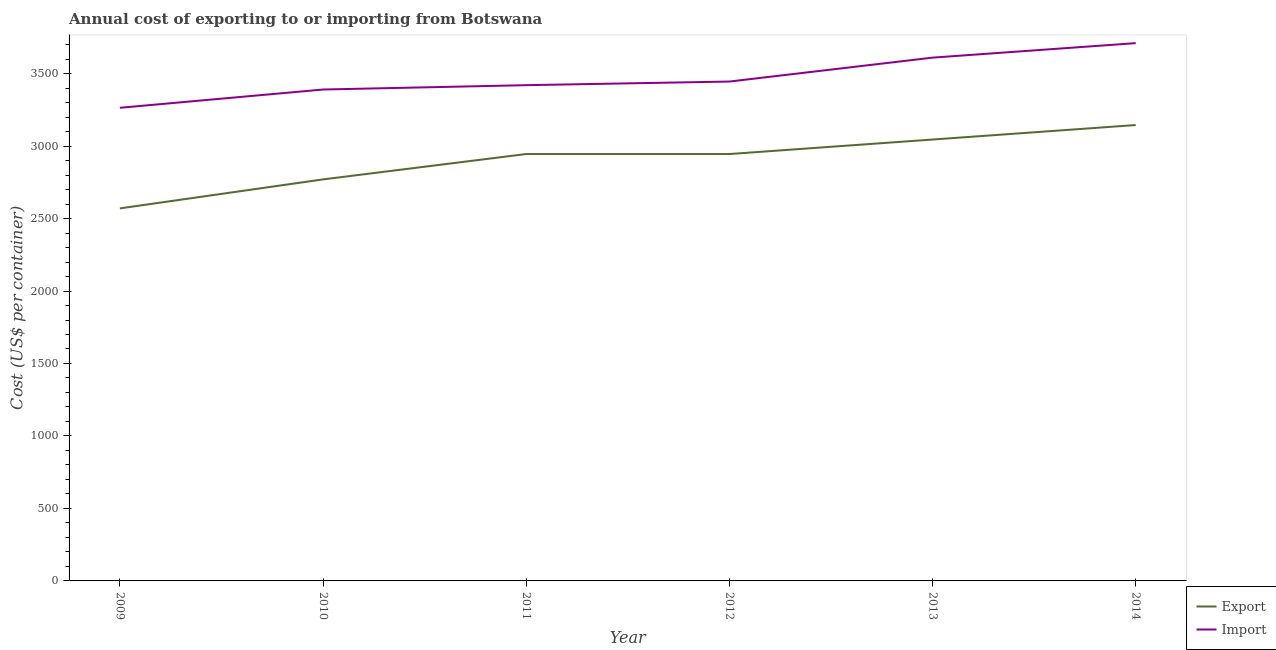What is the export cost in 2010?
Provide a short and direct response. 2770. Across all years, what is the maximum import cost?
Offer a terse response. 3710. Across all years, what is the minimum export cost?
Keep it short and to the point. 2570. In which year was the export cost minimum?
Provide a succinct answer. 2009. What is the total export cost in the graph?
Offer a very short reply. 1.74e+04. What is the difference between the export cost in 2010 and that in 2013?
Your response must be concise. -275. What is the difference between the import cost in 2013 and the export cost in 2012?
Provide a short and direct response. 665. What is the average export cost per year?
Give a very brief answer. 2903.33. In the year 2011, what is the difference between the import cost and export cost?
Offer a very short reply. 475. In how many years, is the import cost greater than 1700 US$?
Provide a short and direct response. 6. What is the ratio of the import cost in 2013 to that in 2014?
Your answer should be compact. 0.97. Is the import cost in 2010 less than that in 2012?
Your answer should be very brief. Yes. Is the difference between the import cost in 2009 and 2014 greater than the difference between the export cost in 2009 and 2014?
Provide a succinct answer. Yes. What is the difference between the highest and the second highest export cost?
Your answer should be compact. 100. What is the difference between the highest and the lowest export cost?
Provide a short and direct response. 575. In how many years, is the export cost greater than the average export cost taken over all years?
Your answer should be very brief. 4. Is the sum of the export cost in 2009 and 2012 greater than the maximum import cost across all years?
Your answer should be compact. Yes. Is the export cost strictly less than the import cost over the years?
Your answer should be compact. Yes. Does the graph contain grids?
Your response must be concise. No. How many legend labels are there?
Provide a short and direct response. 2. How are the legend labels stacked?
Make the answer very short. Vertical. What is the title of the graph?
Give a very brief answer. Annual cost of exporting to or importing from Botswana. What is the label or title of the Y-axis?
Your answer should be very brief. Cost (US$ per container). What is the Cost (US$ per container) of Export in 2009?
Provide a succinct answer. 2570. What is the Cost (US$ per container) of Import in 2009?
Your response must be concise. 3264. What is the Cost (US$ per container) in Export in 2010?
Offer a terse response. 2770. What is the Cost (US$ per container) in Import in 2010?
Offer a terse response. 3390. What is the Cost (US$ per container) in Export in 2011?
Make the answer very short. 2945. What is the Cost (US$ per container) in Import in 2011?
Make the answer very short. 3420. What is the Cost (US$ per container) in Export in 2012?
Offer a very short reply. 2945. What is the Cost (US$ per container) in Import in 2012?
Keep it short and to the point. 3445. What is the Cost (US$ per container) in Export in 2013?
Your answer should be compact. 3045. What is the Cost (US$ per container) in Import in 2013?
Give a very brief answer. 3610. What is the Cost (US$ per container) of Export in 2014?
Keep it short and to the point. 3145. What is the Cost (US$ per container) in Import in 2014?
Offer a very short reply. 3710. Across all years, what is the maximum Cost (US$ per container) of Export?
Make the answer very short. 3145. Across all years, what is the maximum Cost (US$ per container) in Import?
Provide a short and direct response. 3710. Across all years, what is the minimum Cost (US$ per container) of Export?
Provide a short and direct response. 2570. Across all years, what is the minimum Cost (US$ per container) of Import?
Your answer should be compact. 3264. What is the total Cost (US$ per container) of Export in the graph?
Give a very brief answer. 1.74e+04. What is the total Cost (US$ per container) in Import in the graph?
Your answer should be very brief. 2.08e+04. What is the difference between the Cost (US$ per container) of Export in 2009 and that in 2010?
Provide a short and direct response. -200. What is the difference between the Cost (US$ per container) of Import in 2009 and that in 2010?
Provide a succinct answer. -126. What is the difference between the Cost (US$ per container) of Export in 2009 and that in 2011?
Make the answer very short. -375. What is the difference between the Cost (US$ per container) of Import in 2009 and that in 2011?
Ensure brevity in your answer.  -156. What is the difference between the Cost (US$ per container) of Export in 2009 and that in 2012?
Make the answer very short. -375. What is the difference between the Cost (US$ per container) in Import in 2009 and that in 2012?
Keep it short and to the point. -181. What is the difference between the Cost (US$ per container) of Export in 2009 and that in 2013?
Ensure brevity in your answer.  -475. What is the difference between the Cost (US$ per container) of Import in 2009 and that in 2013?
Offer a very short reply. -346. What is the difference between the Cost (US$ per container) of Export in 2009 and that in 2014?
Your answer should be very brief. -575. What is the difference between the Cost (US$ per container) in Import in 2009 and that in 2014?
Offer a terse response. -446. What is the difference between the Cost (US$ per container) of Export in 2010 and that in 2011?
Your answer should be very brief. -175. What is the difference between the Cost (US$ per container) of Export in 2010 and that in 2012?
Your response must be concise. -175. What is the difference between the Cost (US$ per container) of Import in 2010 and that in 2012?
Offer a terse response. -55. What is the difference between the Cost (US$ per container) in Export in 2010 and that in 2013?
Keep it short and to the point. -275. What is the difference between the Cost (US$ per container) of Import in 2010 and that in 2013?
Provide a short and direct response. -220. What is the difference between the Cost (US$ per container) of Export in 2010 and that in 2014?
Give a very brief answer. -375. What is the difference between the Cost (US$ per container) of Import in 2010 and that in 2014?
Provide a short and direct response. -320. What is the difference between the Cost (US$ per container) of Export in 2011 and that in 2012?
Provide a short and direct response. 0. What is the difference between the Cost (US$ per container) in Import in 2011 and that in 2012?
Offer a very short reply. -25. What is the difference between the Cost (US$ per container) of Export in 2011 and that in 2013?
Ensure brevity in your answer.  -100. What is the difference between the Cost (US$ per container) in Import in 2011 and that in 2013?
Your answer should be compact. -190. What is the difference between the Cost (US$ per container) in Export in 2011 and that in 2014?
Offer a very short reply. -200. What is the difference between the Cost (US$ per container) of Import in 2011 and that in 2014?
Your answer should be very brief. -290. What is the difference between the Cost (US$ per container) of Export in 2012 and that in 2013?
Ensure brevity in your answer.  -100. What is the difference between the Cost (US$ per container) of Import in 2012 and that in 2013?
Offer a terse response. -165. What is the difference between the Cost (US$ per container) in Export in 2012 and that in 2014?
Ensure brevity in your answer.  -200. What is the difference between the Cost (US$ per container) in Import in 2012 and that in 2014?
Offer a very short reply. -265. What is the difference between the Cost (US$ per container) in Export in 2013 and that in 2014?
Provide a short and direct response. -100. What is the difference between the Cost (US$ per container) in Import in 2013 and that in 2014?
Provide a short and direct response. -100. What is the difference between the Cost (US$ per container) in Export in 2009 and the Cost (US$ per container) in Import in 2010?
Offer a very short reply. -820. What is the difference between the Cost (US$ per container) in Export in 2009 and the Cost (US$ per container) in Import in 2011?
Offer a terse response. -850. What is the difference between the Cost (US$ per container) in Export in 2009 and the Cost (US$ per container) in Import in 2012?
Your answer should be compact. -875. What is the difference between the Cost (US$ per container) in Export in 2009 and the Cost (US$ per container) in Import in 2013?
Your response must be concise. -1040. What is the difference between the Cost (US$ per container) in Export in 2009 and the Cost (US$ per container) in Import in 2014?
Your answer should be compact. -1140. What is the difference between the Cost (US$ per container) of Export in 2010 and the Cost (US$ per container) of Import in 2011?
Ensure brevity in your answer.  -650. What is the difference between the Cost (US$ per container) in Export in 2010 and the Cost (US$ per container) in Import in 2012?
Offer a very short reply. -675. What is the difference between the Cost (US$ per container) in Export in 2010 and the Cost (US$ per container) in Import in 2013?
Ensure brevity in your answer.  -840. What is the difference between the Cost (US$ per container) of Export in 2010 and the Cost (US$ per container) of Import in 2014?
Offer a very short reply. -940. What is the difference between the Cost (US$ per container) of Export in 2011 and the Cost (US$ per container) of Import in 2012?
Offer a terse response. -500. What is the difference between the Cost (US$ per container) in Export in 2011 and the Cost (US$ per container) in Import in 2013?
Offer a very short reply. -665. What is the difference between the Cost (US$ per container) of Export in 2011 and the Cost (US$ per container) of Import in 2014?
Give a very brief answer. -765. What is the difference between the Cost (US$ per container) of Export in 2012 and the Cost (US$ per container) of Import in 2013?
Ensure brevity in your answer.  -665. What is the difference between the Cost (US$ per container) in Export in 2012 and the Cost (US$ per container) in Import in 2014?
Offer a very short reply. -765. What is the difference between the Cost (US$ per container) in Export in 2013 and the Cost (US$ per container) in Import in 2014?
Keep it short and to the point. -665. What is the average Cost (US$ per container) of Export per year?
Keep it short and to the point. 2903.33. What is the average Cost (US$ per container) of Import per year?
Your answer should be very brief. 3473.17. In the year 2009, what is the difference between the Cost (US$ per container) of Export and Cost (US$ per container) of Import?
Your answer should be compact. -694. In the year 2010, what is the difference between the Cost (US$ per container) in Export and Cost (US$ per container) in Import?
Make the answer very short. -620. In the year 2011, what is the difference between the Cost (US$ per container) in Export and Cost (US$ per container) in Import?
Keep it short and to the point. -475. In the year 2012, what is the difference between the Cost (US$ per container) of Export and Cost (US$ per container) of Import?
Your response must be concise. -500. In the year 2013, what is the difference between the Cost (US$ per container) in Export and Cost (US$ per container) in Import?
Make the answer very short. -565. In the year 2014, what is the difference between the Cost (US$ per container) of Export and Cost (US$ per container) of Import?
Keep it short and to the point. -565. What is the ratio of the Cost (US$ per container) of Export in 2009 to that in 2010?
Your answer should be very brief. 0.93. What is the ratio of the Cost (US$ per container) in Import in 2009 to that in 2010?
Provide a short and direct response. 0.96. What is the ratio of the Cost (US$ per container) of Export in 2009 to that in 2011?
Give a very brief answer. 0.87. What is the ratio of the Cost (US$ per container) in Import in 2009 to that in 2011?
Keep it short and to the point. 0.95. What is the ratio of the Cost (US$ per container) of Export in 2009 to that in 2012?
Offer a very short reply. 0.87. What is the ratio of the Cost (US$ per container) of Import in 2009 to that in 2012?
Ensure brevity in your answer.  0.95. What is the ratio of the Cost (US$ per container) of Export in 2009 to that in 2013?
Offer a very short reply. 0.84. What is the ratio of the Cost (US$ per container) in Import in 2009 to that in 2013?
Your answer should be very brief. 0.9. What is the ratio of the Cost (US$ per container) of Export in 2009 to that in 2014?
Offer a very short reply. 0.82. What is the ratio of the Cost (US$ per container) of Import in 2009 to that in 2014?
Offer a terse response. 0.88. What is the ratio of the Cost (US$ per container) of Export in 2010 to that in 2011?
Make the answer very short. 0.94. What is the ratio of the Cost (US$ per container) of Import in 2010 to that in 2011?
Provide a short and direct response. 0.99. What is the ratio of the Cost (US$ per container) in Export in 2010 to that in 2012?
Provide a short and direct response. 0.94. What is the ratio of the Cost (US$ per container) in Import in 2010 to that in 2012?
Ensure brevity in your answer.  0.98. What is the ratio of the Cost (US$ per container) in Export in 2010 to that in 2013?
Keep it short and to the point. 0.91. What is the ratio of the Cost (US$ per container) in Import in 2010 to that in 2013?
Keep it short and to the point. 0.94. What is the ratio of the Cost (US$ per container) of Export in 2010 to that in 2014?
Provide a short and direct response. 0.88. What is the ratio of the Cost (US$ per container) of Import in 2010 to that in 2014?
Your answer should be compact. 0.91. What is the ratio of the Cost (US$ per container) in Import in 2011 to that in 2012?
Keep it short and to the point. 0.99. What is the ratio of the Cost (US$ per container) of Export in 2011 to that in 2013?
Keep it short and to the point. 0.97. What is the ratio of the Cost (US$ per container) of Export in 2011 to that in 2014?
Offer a terse response. 0.94. What is the ratio of the Cost (US$ per container) of Import in 2011 to that in 2014?
Your answer should be very brief. 0.92. What is the ratio of the Cost (US$ per container) of Export in 2012 to that in 2013?
Provide a short and direct response. 0.97. What is the ratio of the Cost (US$ per container) of Import in 2012 to that in 2013?
Your answer should be very brief. 0.95. What is the ratio of the Cost (US$ per container) of Export in 2012 to that in 2014?
Give a very brief answer. 0.94. What is the ratio of the Cost (US$ per container) in Export in 2013 to that in 2014?
Offer a very short reply. 0.97. What is the ratio of the Cost (US$ per container) of Import in 2013 to that in 2014?
Make the answer very short. 0.97. What is the difference between the highest and the second highest Cost (US$ per container) of Export?
Your response must be concise. 100. What is the difference between the highest and the lowest Cost (US$ per container) in Export?
Your response must be concise. 575. What is the difference between the highest and the lowest Cost (US$ per container) in Import?
Provide a short and direct response. 446. 